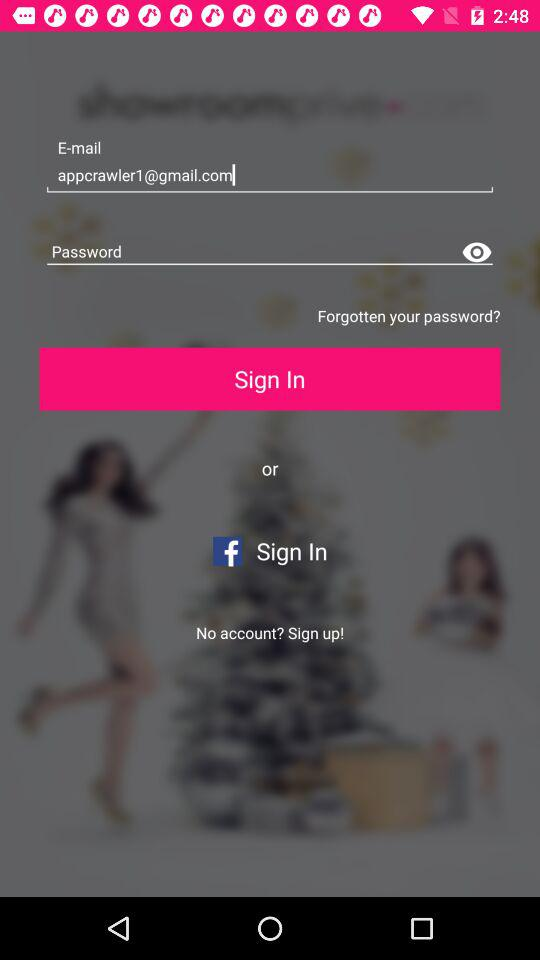What application is used to sign in? The application used to sign in is "Facebook". 